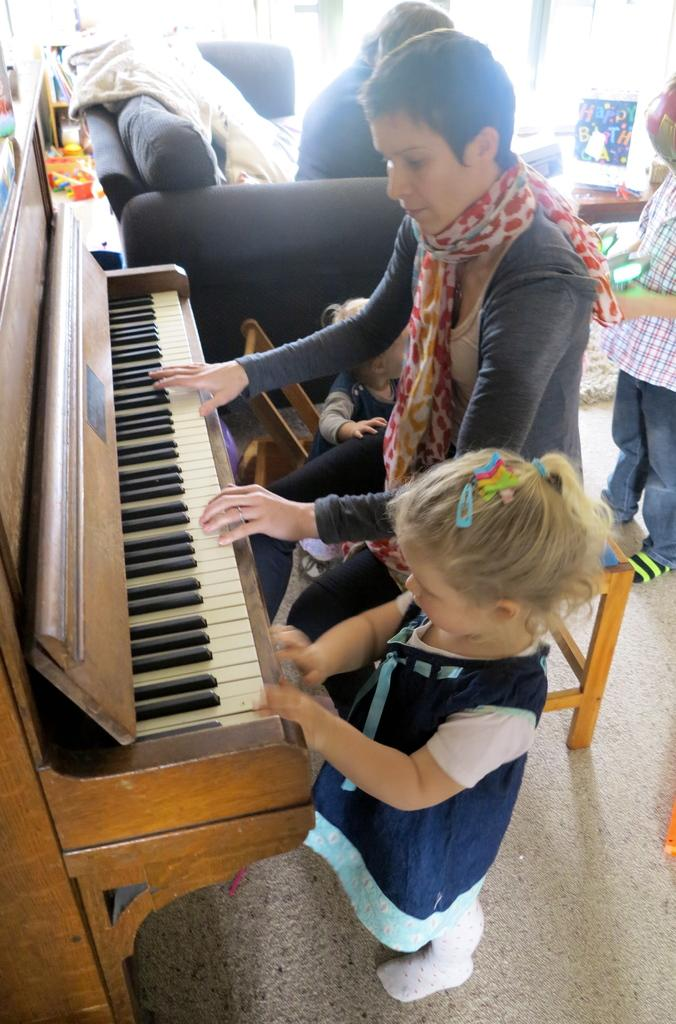Who is the main subject in the image? There is a woman in the image. What is the woman doing in the image? The woman is sitting and playing a piano. Is there anyone else in the image besides the woman? Yes, there is a girl in the image. What is the girl doing in the image? The girl is standing beside the woman. How many dogs are present in the image? There are no dogs present in the image. What type of drink is the woman holding while playing the piano? The image does not show the woman holding any drink while playing the piano. 